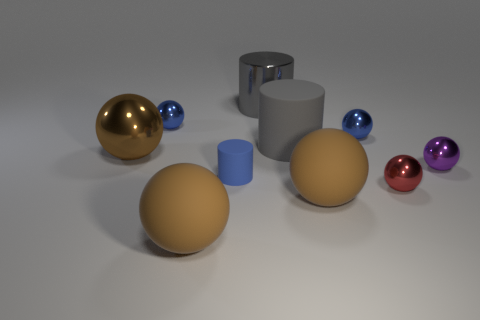Subtract all gray cylinders. How many brown spheres are left? 3 Subtract 1 balls. How many balls are left? 6 Subtract all big brown shiny spheres. How many spheres are left? 6 Subtract all purple spheres. How many spheres are left? 6 Subtract all purple spheres. Subtract all brown cylinders. How many spheres are left? 6 Subtract all balls. How many objects are left? 3 Add 6 rubber objects. How many rubber objects are left? 10 Add 2 red things. How many red things exist? 3 Subtract 0 gray blocks. How many objects are left? 10 Subtract all large things. Subtract all big metal things. How many objects are left? 3 